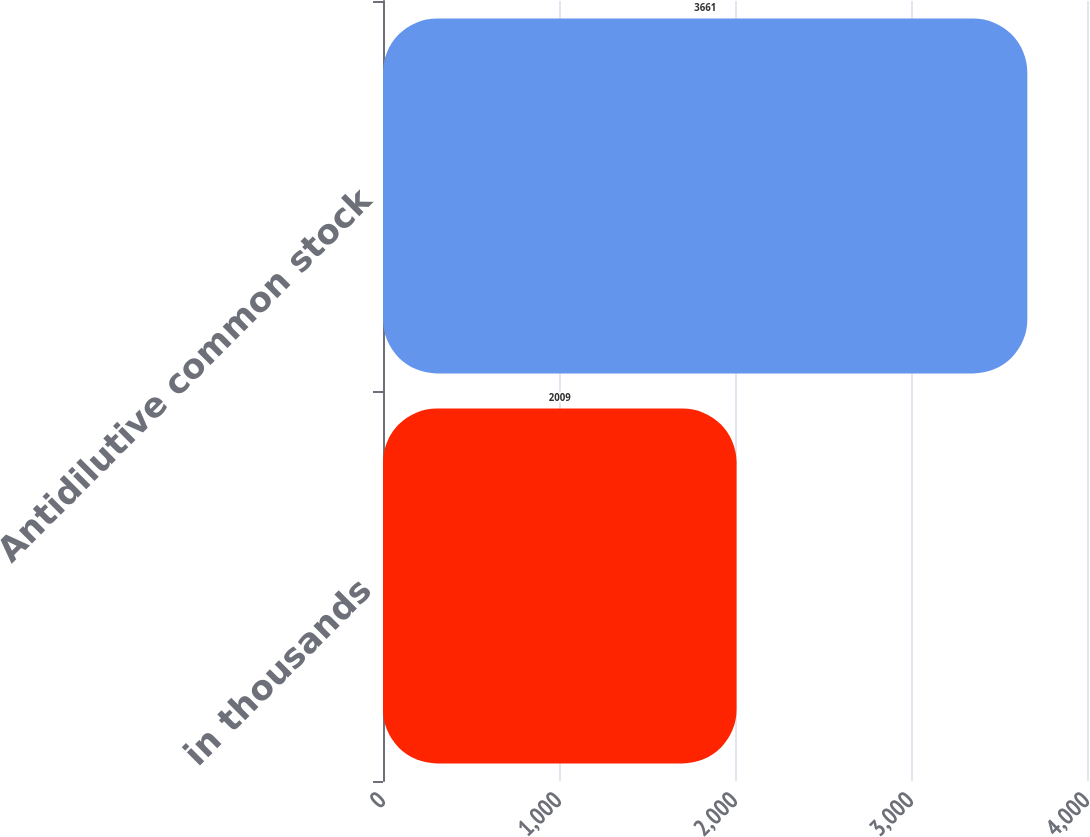<chart> <loc_0><loc_0><loc_500><loc_500><bar_chart><fcel>in thousands<fcel>Antidilutive common stock<nl><fcel>2009<fcel>3661<nl></chart> 